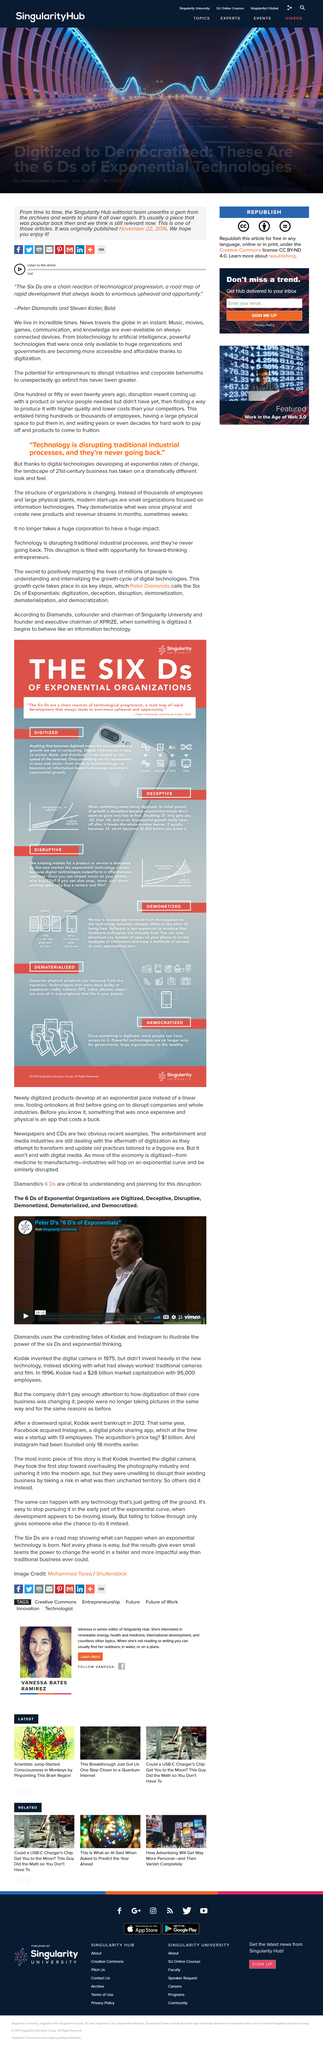Indicate a few pertinent items in this graphic. Kodak invented the digital camera in 1975. The company that Diamandis contrasted Instagram with is Kodak. In 1996, Kodak had approximately 95,000 employees. 